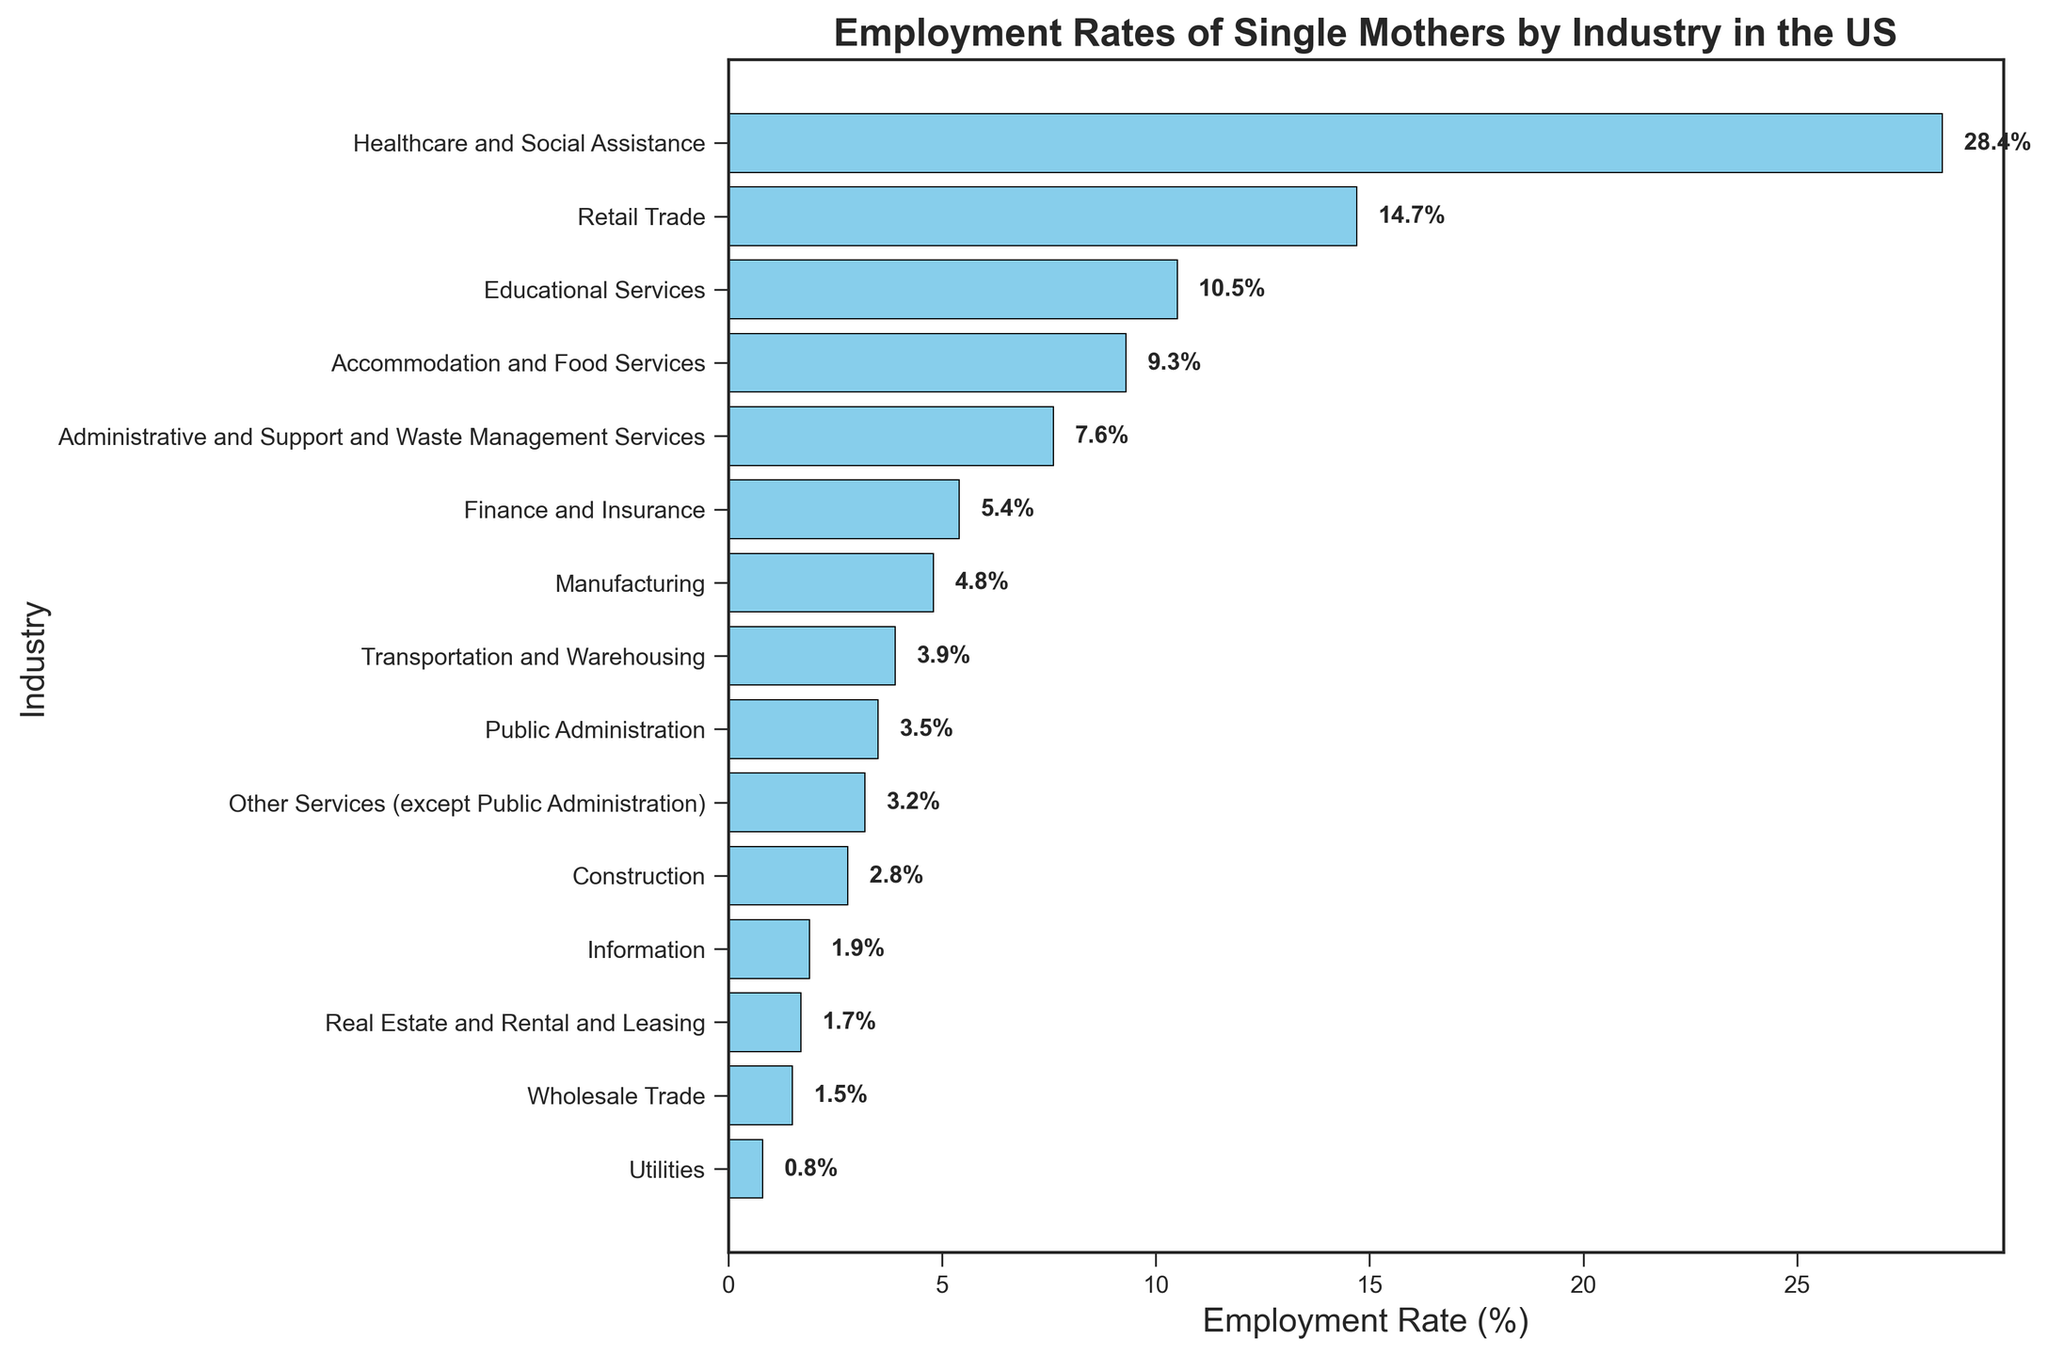What's the industry with the highest employment rate for single mothers? To find this, look at the topmost bar in the figure, which represents the industry with the highest employment rate.
Answer: Healthcare and Social Assistance What's the combined employment rate of the top three industries? Sum the employment rates of the industries at the top three positions in the figure: Healthcare and Social Assistance (28.4%), Retail Trade (14.7%), and Educational Services (10.5%). 28.4 + 14.7 + 10.5 = 53.6%
Answer: 53.6% Which industry has a higher employment rate, Public Administration or Finance and Insurance? Compare the lengths and the labels of the bars for Public Administration (3.5%) and Finance and Insurance (5.4%). Finance and Insurance has a higher employment rate.
Answer: Finance and Insurance How many industries have an employment rate below 5%? Count the number of bars that visually fall below the 5% mark. These industries are Manufacturing (4.8%), Transportation and Warehousing (3.9%), Public Administration (3.5%), Other Services (except Public Administration) (3.2%), Construction (2.8%), Information (1.9%), Real Estate and Rental and Leasing (1.7%), Wholesale Trade (1.5%), and Utilities (0.8%).
Answer: 9 industries What is the average employment rate among the bottom five industries? Identify the bottom five industries: Information, Real Estate and Rental and Leasing, Wholesale Trade, Utilities, and Construction. Their rates are 1.9%, 1.7%, 1.5%, 0.8%, and 2.8%, respectively. Sum these rates: 1.9 + 1.7 + 1.5 + 0.8 + 2.8 = 8.7. Then, divide by 5: 8.7 / 5 = 1.74.
Answer: 1.74% Between Educational Services and Administrative and Support and Waste Management Services, which industry employs more single mothers? Compare the bars for Educational Services (10.5%) and Administrative and Support and Waste Management Services (7.6%) by looking at their lengths. Educational Services employs more single mothers.
Answer: Educational Services What is the employment rate difference between the highest and lowest industry? Subtract the employment rate of the lowest industry (Utilities, 0.8%) from the highest industry (Healthcare and Social Assistance, 28.4%). 28.4 - 0.8 = 27.6%
Answer: 27.6% Is the employment rate in Finance and Insurance greater than the total of Utilities and Real Estate and Rental and Leasing combined? Add the employment rates of Utilities (0.8%) and Real Estate and Rental and Leasing (1.7%) first: 0.8 + 1.7 = 2.5%. Compare this sum to the employment rate of Finance and Insurance (5.4%). Yes, 5.4% is greater than 2.5%.
Answer: Yes 